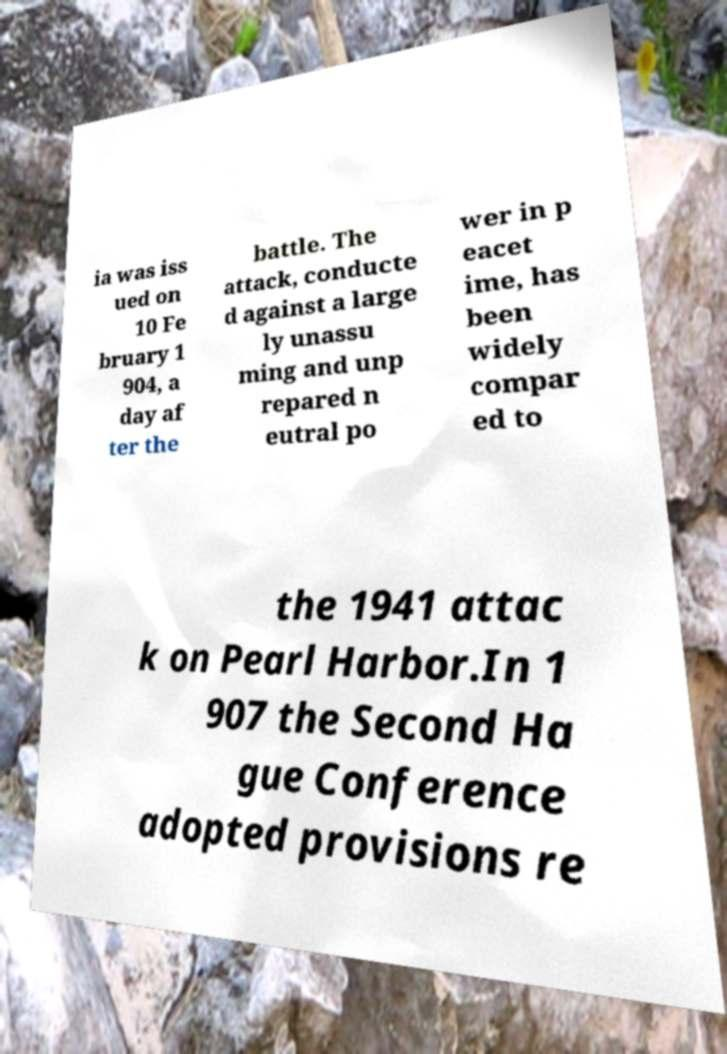Can you read and provide the text displayed in the image?This photo seems to have some interesting text. Can you extract and type it out for me? ia was iss ued on 10 Fe bruary 1 904, a day af ter the battle. The attack, conducte d against a large ly unassu ming and unp repared n eutral po wer in p eacet ime, has been widely compar ed to the 1941 attac k on Pearl Harbor.In 1 907 the Second Ha gue Conference adopted provisions re 